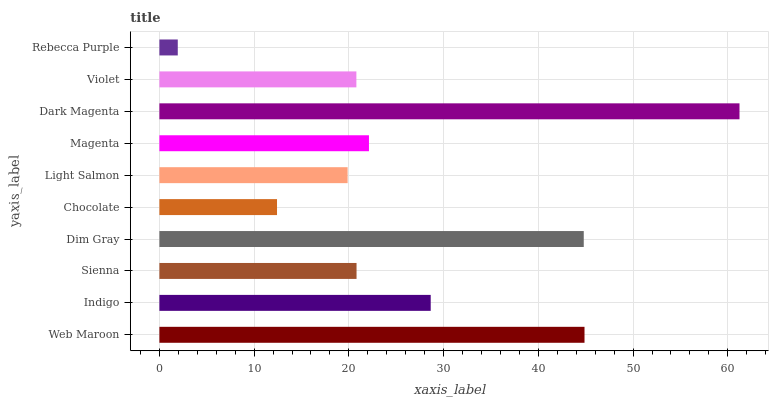Is Rebecca Purple the minimum?
Answer yes or no. Yes. Is Dark Magenta the maximum?
Answer yes or no. Yes. Is Indigo the minimum?
Answer yes or no. No. Is Indigo the maximum?
Answer yes or no. No. Is Web Maroon greater than Indigo?
Answer yes or no. Yes. Is Indigo less than Web Maroon?
Answer yes or no. Yes. Is Indigo greater than Web Maroon?
Answer yes or no. No. Is Web Maroon less than Indigo?
Answer yes or no. No. Is Magenta the high median?
Answer yes or no. Yes. Is Sienna the low median?
Answer yes or no. Yes. Is Indigo the high median?
Answer yes or no. No. Is Dim Gray the low median?
Answer yes or no. No. 